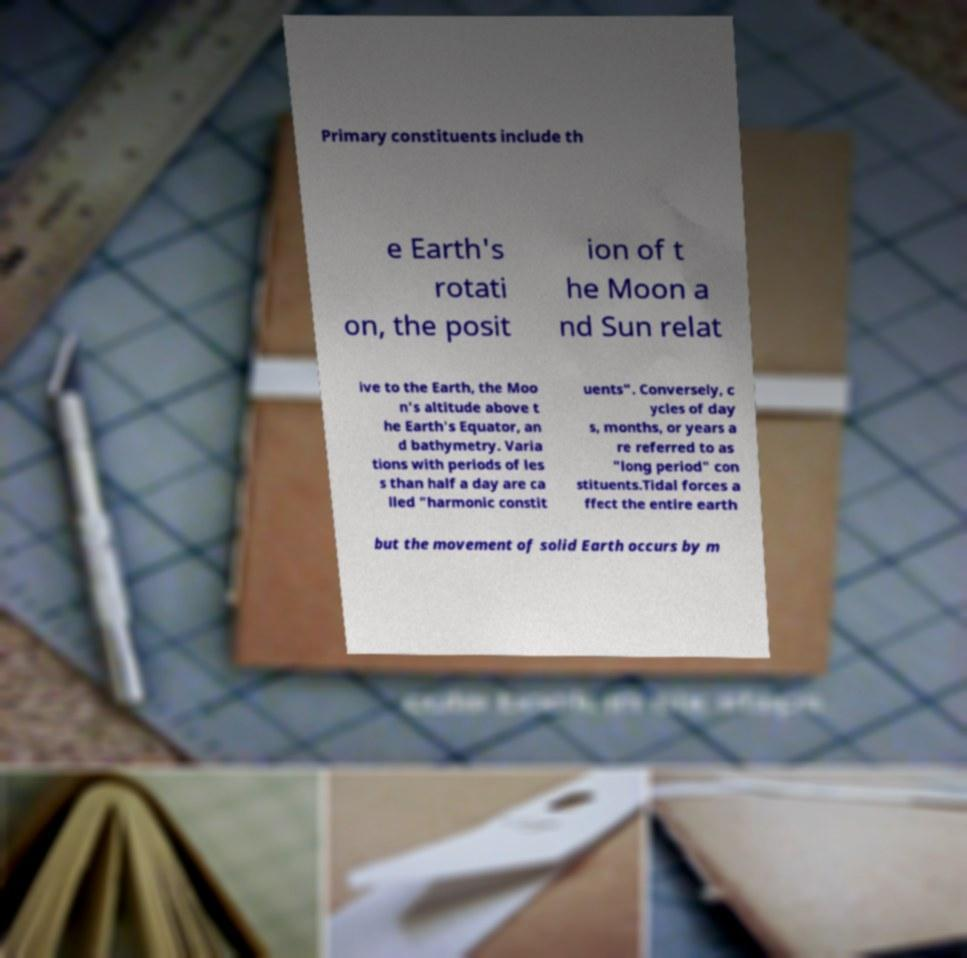Please identify and transcribe the text found in this image. Primary constituents include th e Earth's rotati on, the posit ion of t he Moon a nd Sun relat ive to the Earth, the Moo n's altitude above t he Earth's Equator, an d bathymetry. Varia tions with periods of les s than half a day are ca lled "harmonic constit uents". Conversely, c ycles of day s, months, or years a re referred to as "long period" con stituents.Tidal forces a ffect the entire earth but the movement of solid Earth occurs by m 